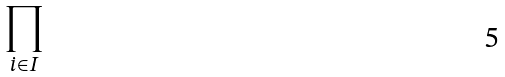<formula> <loc_0><loc_0><loc_500><loc_500>\prod _ { i \in I }</formula> 